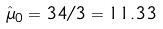<formula> <loc_0><loc_0><loc_500><loc_500>\hat { \mu } _ { 0 } = 3 4 / 3 = 1 1 . 3 3</formula> 